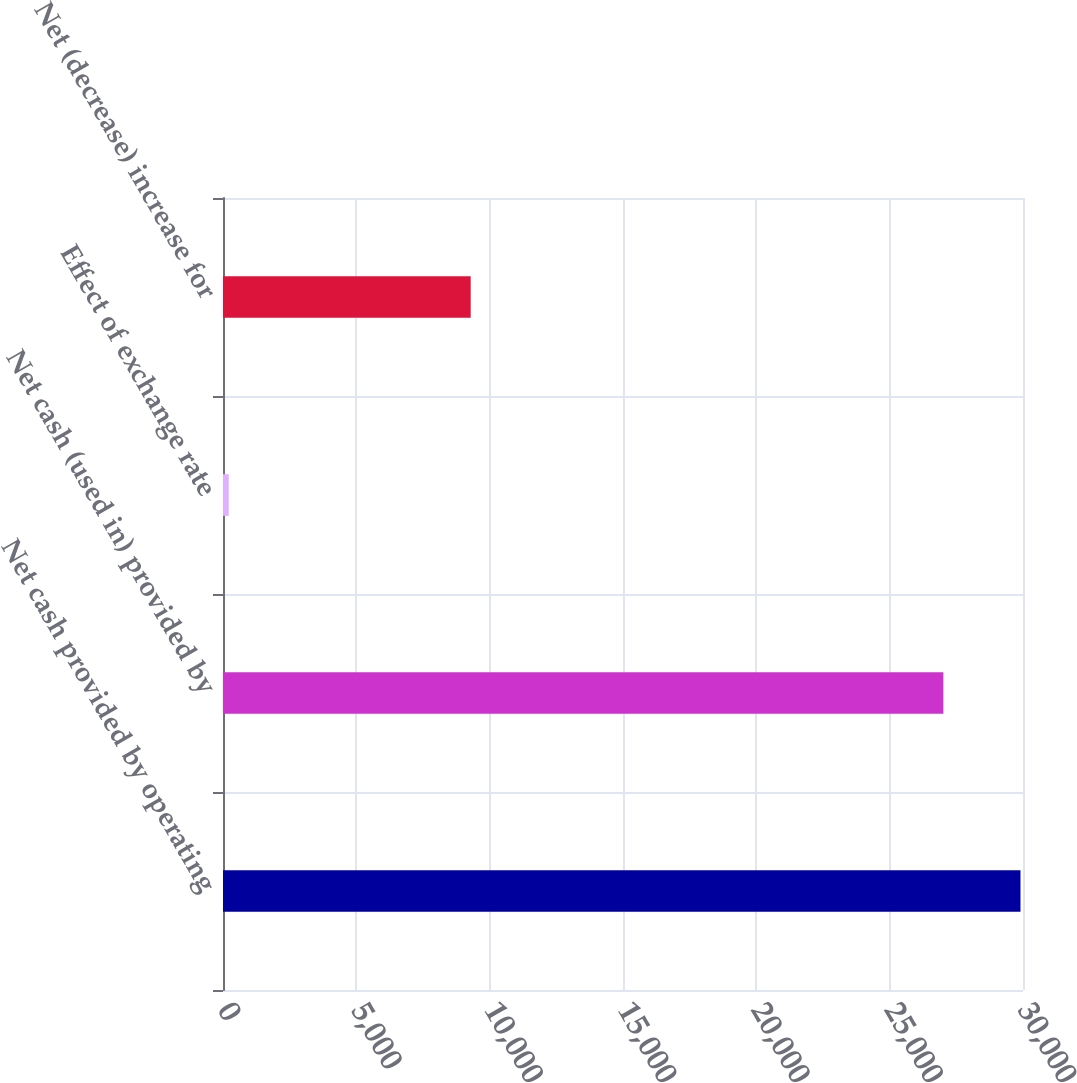Convert chart. <chart><loc_0><loc_0><loc_500><loc_500><bar_chart><fcel>Net cash provided by operating<fcel>Net cash (used in) provided by<fcel>Effect of exchange rate<fcel>Net (decrease) increase for<nl><fcel>29905.5<fcel>27015<fcel>215<fcel>9289<nl></chart> 